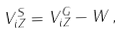<formula> <loc_0><loc_0><loc_500><loc_500>V _ { i Z } ^ { S } = V _ { i Z } ^ { G } - W \, ,</formula> 